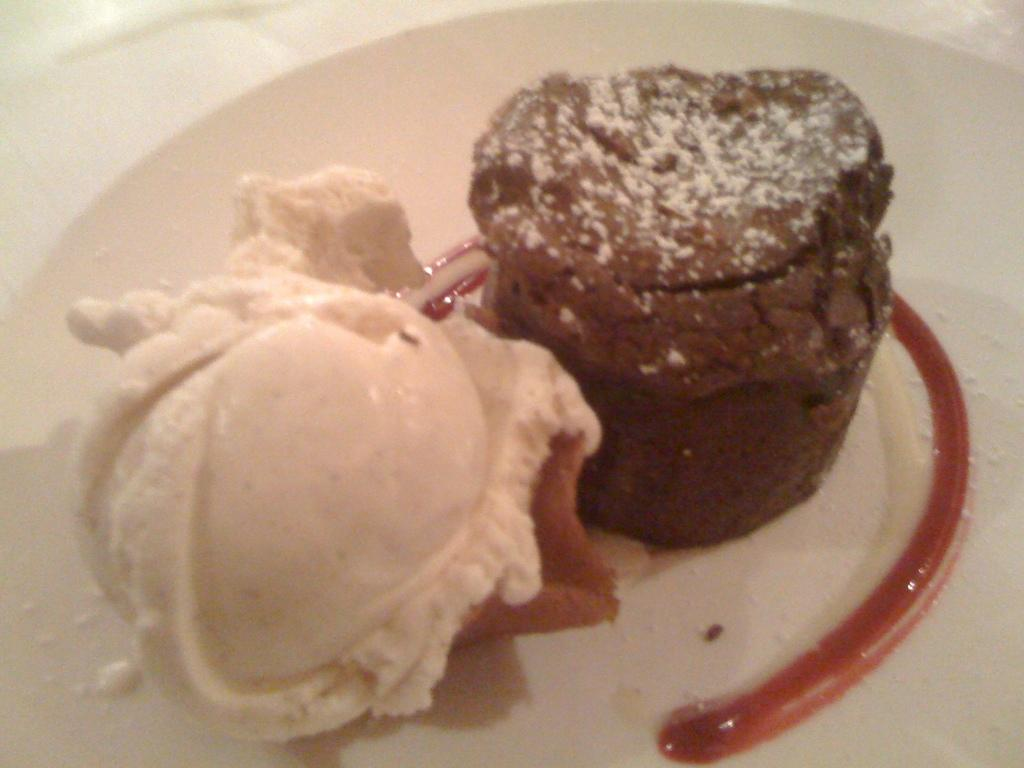What is the main subject of the image? The main subject of the image is a food item on a plate. Can you describe the food item in more detail? Unfortunately, the specific food item cannot be identified from the provided facts. What is the plate made of? The material of the plate cannot be determined from the provided facts. Who is the creator of the plate's edge in the image? There is no information about the creator of the plate's edge in the image, as the focus is on the food item and not the plate itself. 